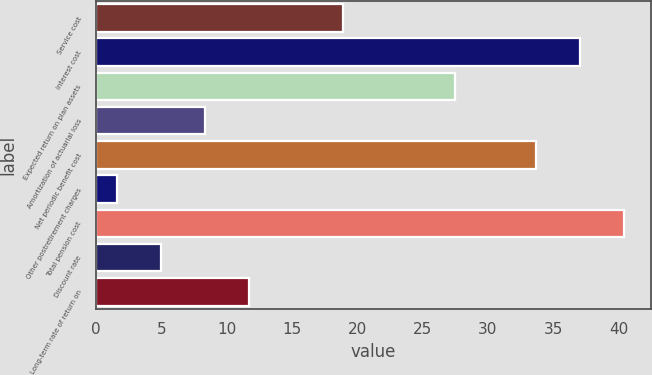Convert chart to OTSL. <chart><loc_0><loc_0><loc_500><loc_500><bar_chart><fcel>Service cost<fcel>Interest cost<fcel>Expected return on plan assets<fcel>Amortization of actuarial loss<fcel>Net periodic benefit cost<fcel>Other postretirement charges<fcel>Total pension cost<fcel>Discount rate<fcel>Long-term rate of return on<nl><fcel>18.9<fcel>37.07<fcel>27.5<fcel>8.34<fcel>33.7<fcel>1.6<fcel>40.44<fcel>4.97<fcel>11.71<nl></chart> 